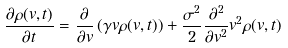Convert formula to latex. <formula><loc_0><loc_0><loc_500><loc_500>\frac { \partial \rho ( v , t ) } { \partial t } = \frac { \partial } { \partial v } \left ( \gamma v \rho ( v , t ) \right ) + \frac { \sigma ^ { 2 } } { 2 } \frac { \partial ^ { 2 } } { \partial v ^ { 2 } } v ^ { 2 } \rho ( v , t )</formula> 